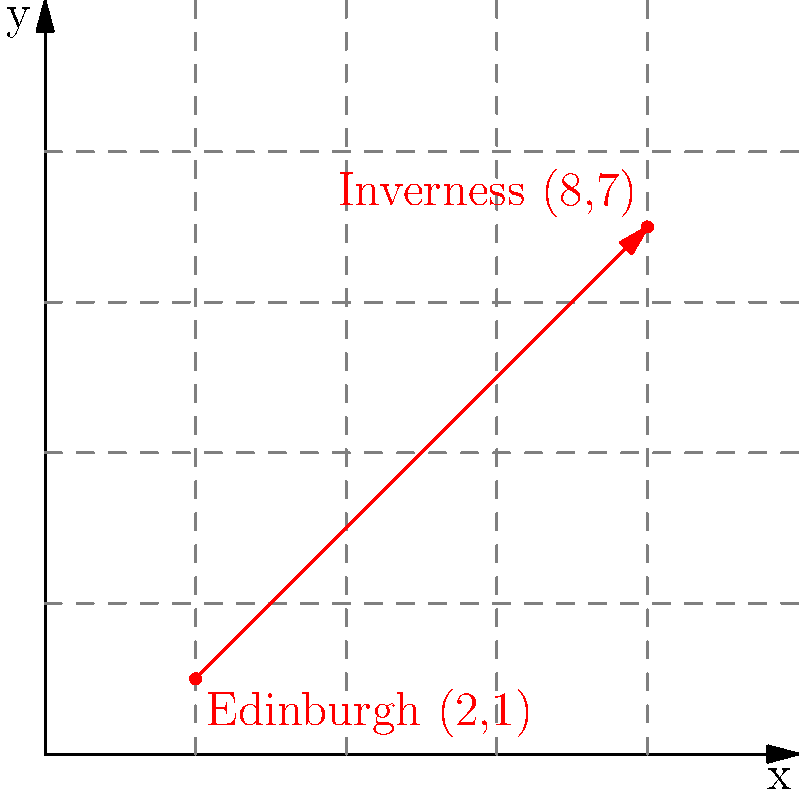In 1566, Mary, Queen of Scots traveled from Edinburgh to Inverness. On the coordinate plane above, Edinburgh is represented by the point (2,1) and Inverness by (8,7). Calculate the slope of Mary's travel route. To find the slope of Mary, Queen of Scots' travel route, we'll use the slope formula:

$$ m = \frac{y_2 - y_1}{x_2 - x_1} $$

Where $(x_1, y_1)$ represents Edinburgh (2,1) and $(x_2, y_2)$ represents Inverness (8,7).

Step 1: Identify the coordinates
Edinburgh: $(x_1, y_1) = (2, 1)$
Inverness: $(x_2, y_2) = (8, 7)$

Step 2: Plug the values into the slope formula
$$ m = \frac{7 - 1}{8 - 2} $$

Step 3: Simplify the numerator and denominator
$$ m = \frac{6}{6} $$

Step 4: Perform the division
$$ m = 1 $$

Therefore, the slope of Mary's travel route from Edinburgh to Inverness in 1566 is 1.
Answer: 1 